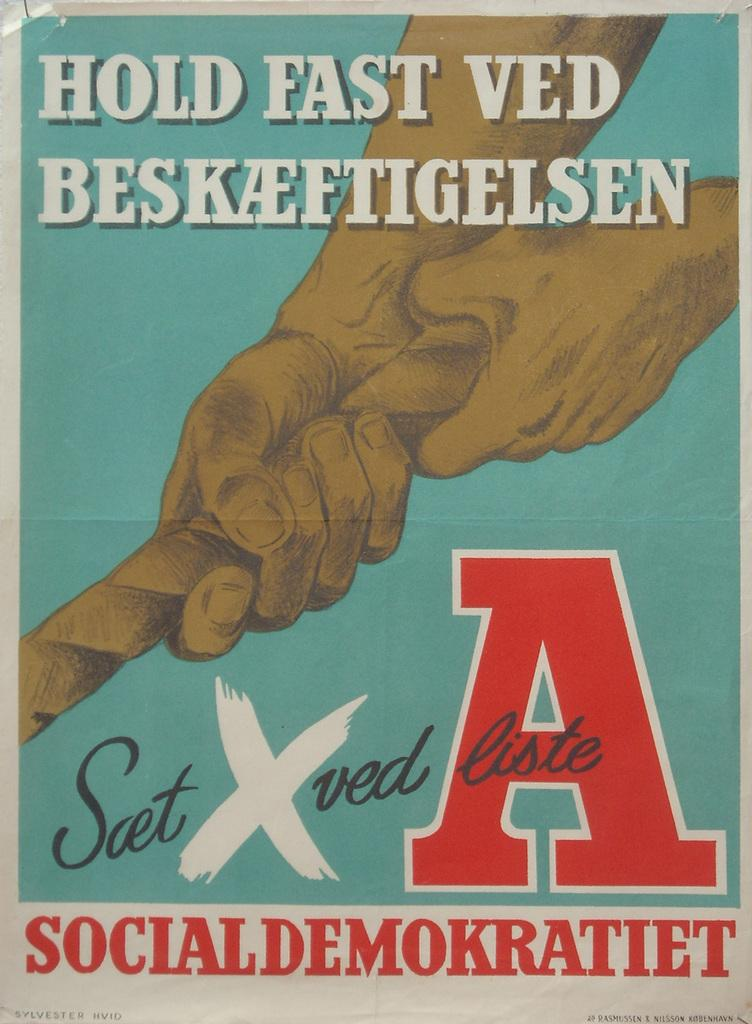<image>
Relay a brief, clear account of the picture shown. A poster with hands holding a rope above the word socialdemokratiet. 